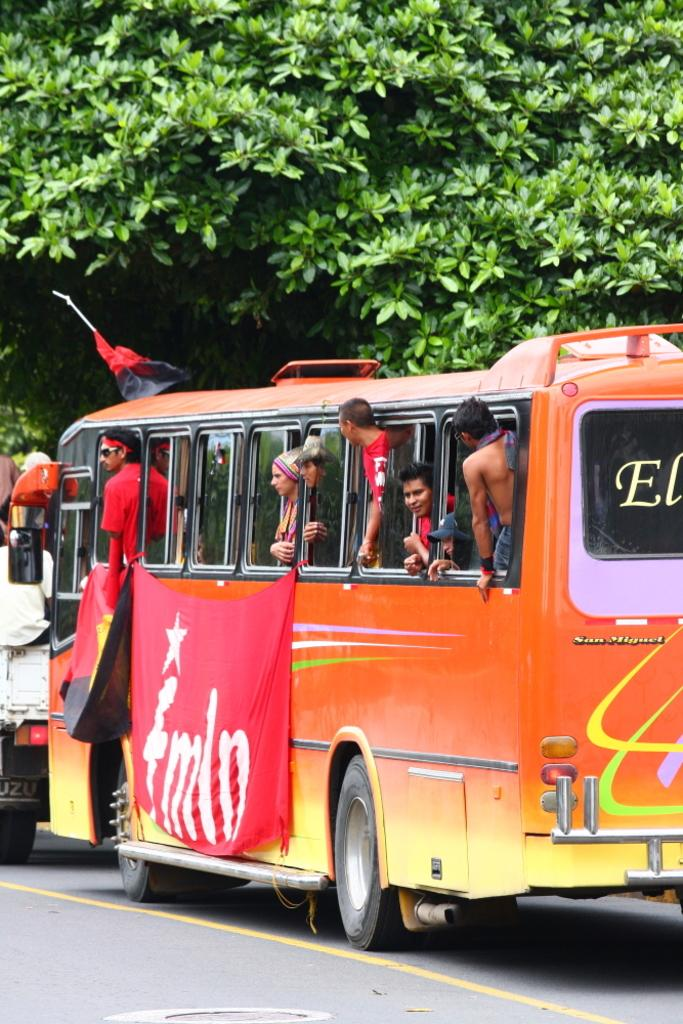What is happening on the road in the image? There are vehicles on the road in the image. Can you describe the people in the image? There are people in a bus in the image. What can be seen in the background of the image? There are trees in the background of the image. What else is present in the image besides the vehicles and people? Flags are present in the image. What type of pan is being used to cook the experience in the image? There is no pan or experience being cooked in the image. 